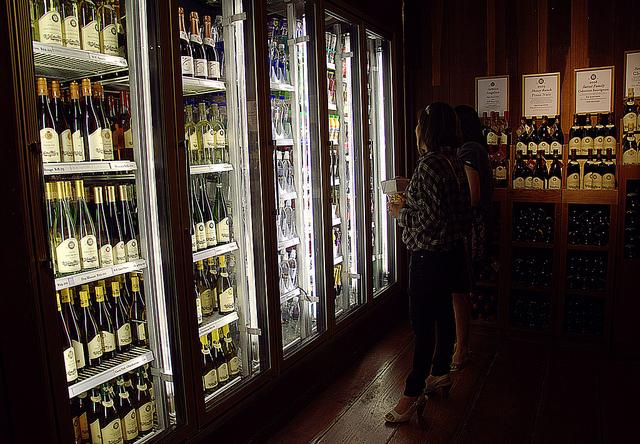Where are these two girls at? wine store 